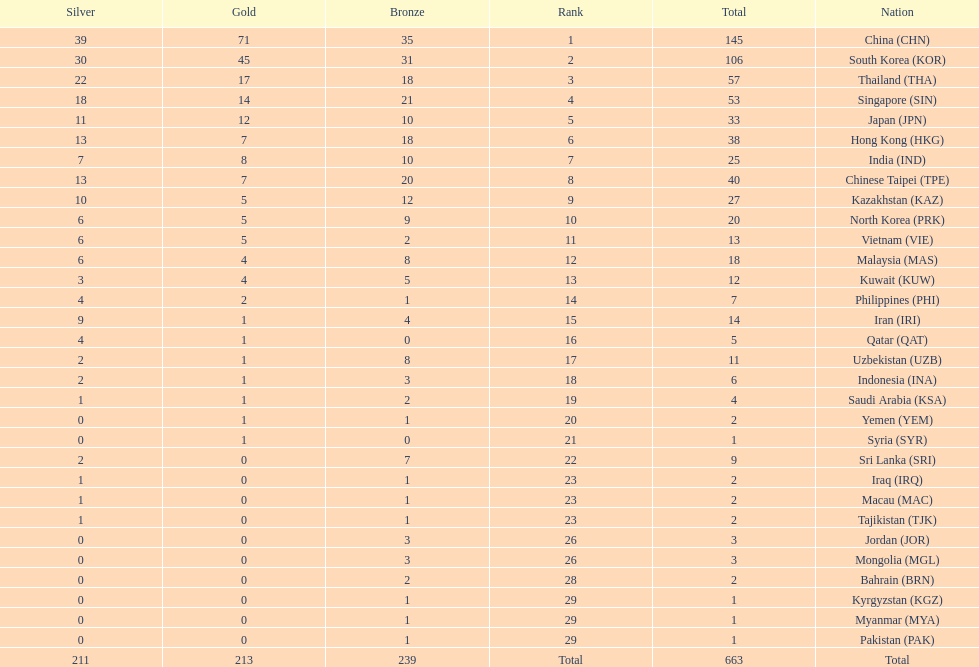What is the number of nations with a minimum of ten bronze medals? 9. 